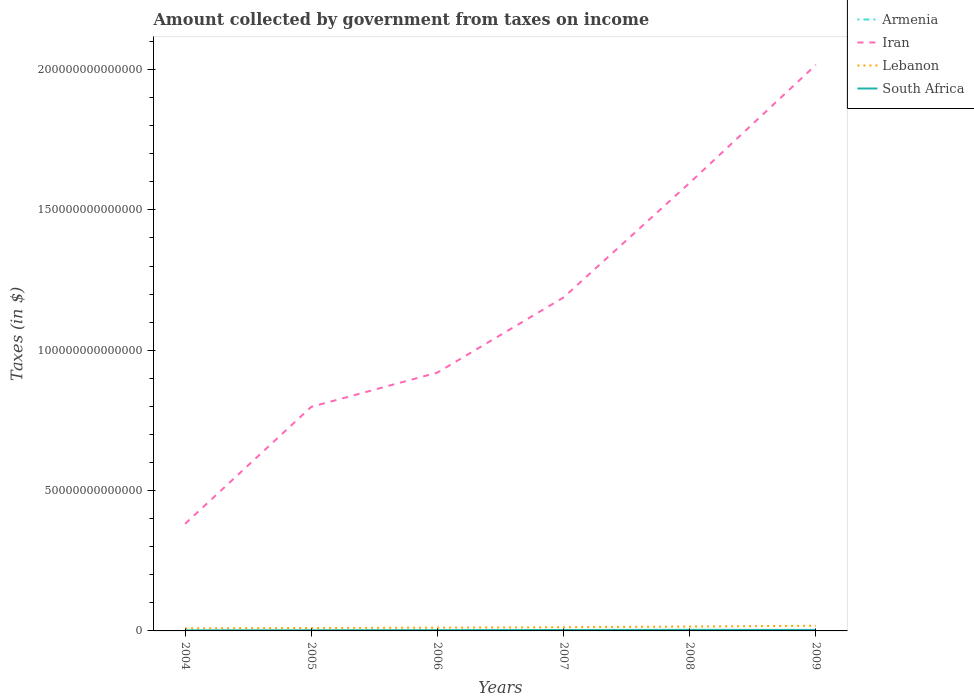Across all years, what is the maximum amount collected by government from taxes on income in South Africa?
Provide a short and direct response. 1.95e+11. What is the total amount collected by government from taxes on income in Iran in the graph?
Give a very brief answer. -1.22e+14. What is the difference between the highest and the second highest amount collected by government from taxes on income in Lebanon?
Give a very brief answer. 9.31e+11. Is the amount collected by government from taxes on income in Armenia strictly greater than the amount collected by government from taxes on income in South Africa over the years?
Offer a terse response. Yes. What is the difference between two consecutive major ticks on the Y-axis?
Ensure brevity in your answer.  5.00e+13. Does the graph contain grids?
Make the answer very short. No. How many legend labels are there?
Provide a short and direct response. 4. How are the legend labels stacked?
Your answer should be compact. Vertical. What is the title of the graph?
Give a very brief answer. Amount collected by government from taxes on income. What is the label or title of the Y-axis?
Your response must be concise. Taxes (in $). What is the Taxes (in $) in Armenia in 2004?
Offer a very short reply. 5.24e+1. What is the Taxes (in $) of Iran in 2004?
Your response must be concise. 3.82e+13. What is the Taxes (in $) of Lebanon in 2004?
Provide a succinct answer. 9.08e+11. What is the Taxes (in $) of South Africa in 2004?
Make the answer very short. 1.95e+11. What is the Taxes (in $) in Armenia in 2005?
Provide a short and direct response. 7.32e+1. What is the Taxes (in $) of Iran in 2005?
Your response must be concise. 7.98e+13. What is the Taxes (in $) of Lebanon in 2005?
Provide a short and direct response. 1.05e+12. What is the Taxes (in $) in South Africa in 2005?
Ensure brevity in your answer.  2.31e+11. What is the Taxes (in $) of Armenia in 2006?
Your answer should be compact. 1.01e+11. What is the Taxes (in $) in Iran in 2006?
Offer a terse response. 9.20e+13. What is the Taxes (in $) in Lebanon in 2006?
Provide a short and direct response. 1.17e+12. What is the Taxes (in $) in South Africa in 2006?
Give a very brief answer. 2.80e+11. What is the Taxes (in $) of Armenia in 2007?
Provide a succinct answer. 1.22e+11. What is the Taxes (in $) of Iran in 2007?
Your response must be concise. 1.19e+14. What is the Taxes (in $) in Lebanon in 2007?
Keep it short and to the point. 1.31e+12. What is the Taxes (in $) of South Africa in 2007?
Your response must be concise. 3.32e+11. What is the Taxes (in $) in Armenia in 2008?
Make the answer very short. 1.40e+11. What is the Taxes (in $) in Iran in 2008?
Provide a short and direct response. 1.60e+14. What is the Taxes (in $) of Lebanon in 2008?
Offer a terse response. 1.56e+12. What is the Taxes (in $) in South Africa in 2008?
Provide a succinct answer. 3.83e+11. What is the Taxes (in $) in Armenia in 2009?
Your answer should be compact. 1.42e+11. What is the Taxes (in $) in Iran in 2009?
Provide a short and direct response. 2.02e+14. What is the Taxes (in $) in Lebanon in 2009?
Your answer should be compact. 1.84e+12. What is the Taxes (in $) of South Africa in 2009?
Offer a very short reply. 3.59e+11. Across all years, what is the maximum Taxes (in $) of Armenia?
Make the answer very short. 1.42e+11. Across all years, what is the maximum Taxes (in $) of Iran?
Provide a short and direct response. 2.02e+14. Across all years, what is the maximum Taxes (in $) of Lebanon?
Ensure brevity in your answer.  1.84e+12. Across all years, what is the maximum Taxes (in $) of South Africa?
Provide a short and direct response. 3.83e+11. Across all years, what is the minimum Taxes (in $) in Armenia?
Make the answer very short. 5.24e+1. Across all years, what is the minimum Taxes (in $) of Iran?
Offer a terse response. 3.82e+13. Across all years, what is the minimum Taxes (in $) in Lebanon?
Offer a very short reply. 9.08e+11. Across all years, what is the minimum Taxes (in $) of South Africa?
Your answer should be very brief. 1.95e+11. What is the total Taxes (in $) in Armenia in the graph?
Your response must be concise. 6.31e+11. What is the total Taxes (in $) in Iran in the graph?
Offer a very short reply. 6.90e+14. What is the total Taxes (in $) in Lebanon in the graph?
Your response must be concise. 7.83e+12. What is the total Taxes (in $) in South Africa in the graph?
Your answer should be very brief. 1.78e+12. What is the difference between the Taxes (in $) of Armenia in 2004 and that in 2005?
Provide a succinct answer. -2.07e+1. What is the difference between the Taxes (in $) in Iran in 2004 and that in 2005?
Give a very brief answer. -4.17e+13. What is the difference between the Taxes (in $) in Lebanon in 2004 and that in 2005?
Provide a short and direct response. -1.39e+11. What is the difference between the Taxes (in $) of South Africa in 2004 and that in 2005?
Your answer should be compact. -3.56e+1. What is the difference between the Taxes (in $) in Armenia in 2004 and that in 2006?
Provide a succinct answer. -4.84e+1. What is the difference between the Taxes (in $) in Iran in 2004 and that in 2006?
Provide a short and direct response. -5.39e+13. What is the difference between the Taxes (in $) in Lebanon in 2004 and that in 2006?
Your answer should be compact. -2.58e+11. What is the difference between the Taxes (in $) in South Africa in 2004 and that in 2006?
Provide a succinct answer. -8.48e+1. What is the difference between the Taxes (in $) in Armenia in 2004 and that in 2007?
Offer a very short reply. -6.99e+1. What is the difference between the Taxes (in $) of Iran in 2004 and that in 2007?
Give a very brief answer. -8.06e+13. What is the difference between the Taxes (in $) of Lebanon in 2004 and that in 2007?
Ensure brevity in your answer.  -4.00e+11. What is the difference between the Taxes (in $) in South Africa in 2004 and that in 2007?
Give a very brief answer. -1.37e+11. What is the difference between the Taxes (in $) in Armenia in 2004 and that in 2008?
Offer a very short reply. -8.75e+1. What is the difference between the Taxes (in $) of Iran in 2004 and that in 2008?
Keep it short and to the point. -1.21e+14. What is the difference between the Taxes (in $) of Lebanon in 2004 and that in 2008?
Your answer should be very brief. -6.56e+11. What is the difference between the Taxes (in $) of South Africa in 2004 and that in 2008?
Provide a succinct answer. -1.88e+11. What is the difference between the Taxes (in $) of Armenia in 2004 and that in 2009?
Your answer should be compact. -8.96e+1. What is the difference between the Taxes (in $) in Iran in 2004 and that in 2009?
Provide a short and direct response. -1.63e+14. What is the difference between the Taxes (in $) in Lebanon in 2004 and that in 2009?
Your answer should be very brief. -9.31e+11. What is the difference between the Taxes (in $) in South Africa in 2004 and that in 2009?
Offer a terse response. -1.64e+11. What is the difference between the Taxes (in $) in Armenia in 2005 and that in 2006?
Keep it short and to the point. -2.76e+1. What is the difference between the Taxes (in $) of Iran in 2005 and that in 2006?
Offer a terse response. -1.22e+13. What is the difference between the Taxes (in $) of Lebanon in 2005 and that in 2006?
Provide a short and direct response. -1.19e+11. What is the difference between the Taxes (in $) of South Africa in 2005 and that in 2006?
Keep it short and to the point. -4.92e+1. What is the difference between the Taxes (in $) of Armenia in 2005 and that in 2007?
Provide a succinct answer. -4.92e+1. What is the difference between the Taxes (in $) of Iran in 2005 and that in 2007?
Provide a succinct answer. -3.90e+13. What is the difference between the Taxes (in $) of Lebanon in 2005 and that in 2007?
Offer a terse response. -2.61e+11. What is the difference between the Taxes (in $) in South Africa in 2005 and that in 2007?
Your answer should be very brief. -1.01e+11. What is the difference between the Taxes (in $) of Armenia in 2005 and that in 2008?
Your answer should be compact. -6.68e+1. What is the difference between the Taxes (in $) in Iran in 2005 and that in 2008?
Give a very brief answer. -7.98e+13. What is the difference between the Taxes (in $) in Lebanon in 2005 and that in 2008?
Offer a very short reply. -5.17e+11. What is the difference between the Taxes (in $) in South Africa in 2005 and that in 2008?
Your answer should be very brief. -1.53e+11. What is the difference between the Taxes (in $) of Armenia in 2005 and that in 2009?
Give a very brief answer. -6.89e+1. What is the difference between the Taxes (in $) in Iran in 2005 and that in 2009?
Provide a succinct answer. -1.22e+14. What is the difference between the Taxes (in $) in Lebanon in 2005 and that in 2009?
Make the answer very short. -7.92e+11. What is the difference between the Taxes (in $) in South Africa in 2005 and that in 2009?
Your answer should be compact. -1.28e+11. What is the difference between the Taxes (in $) in Armenia in 2006 and that in 2007?
Your response must be concise. -2.15e+1. What is the difference between the Taxes (in $) of Iran in 2006 and that in 2007?
Your answer should be very brief. -2.68e+13. What is the difference between the Taxes (in $) in Lebanon in 2006 and that in 2007?
Your response must be concise. -1.42e+11. What is the difference between the Taxes (in $) of South Africa in 2006 and that in 2007?
Your answer should be compact. -5.21e+1. What is the difference between the Taxes (in $) in Armenia in 2006 and that in 2008?
Make the answer very short. -3.92e+1. What is the difference between the Taxes (in $) in Iran in 2006 and that in 2008?
Provide a short and direct response. -6.76e+13. What is the difference between the Taxes (in $) of Lebanon in 2006 and that in 2008?
Give a very brief answer. -3.98e+11. What is the difference between the Taxes (in $) of South Africa in 2006 and that in 2008?
Ensure brevity in your answer.  -1.03e+11. What is the difference between the Taxes (in $) of Armenia in 2006 and that in 2009?
Provide a succinct answer. -4.12e+1. What is the difference between the Taxes (in $) in Iran in 2006 and that in 2009?
Keep it short and to the point. -1.10e+14. What is the difference between the Taxes (in $) of Lebanon in 2006 and that in 2009?
Give a very brief answer. -6.73e+11. What is the difference between the Taxes (in $) of South Africa in 2006 and that in 2009?
Make the answer very short. -7.91e+1. What is the difference between the Taxes (in $) of Armenia in 2007 and that in 2008?
Keep it short and to the point. -1.76e+1. What is the difference between the Taxes (in $) in Iran in 2007 and that in 2008?
Offer a very short reply. -4.08e+13. What is the difference between the Taxes (in $) of Lebanon in 2007 and that in 2008?
Provide a succinct answer. -2.56e+11. What is the difference between the Taxes (in $) in South Africa in 2007 and that in 2008?
Make the answer very short. -5.14e+1. What is the difference between the Taxes (in $) of Armenia in 2007 and that in 2009?
Keep it short and to the point. -1.97e+1. What is the difference between the Taxes (in $) of Iran in 2007 and that in 2009?
Ensure brevity in your answer.  -8.29e+13. What is the difference between the Taxes (in $) in Lebanon in 2007 and that in 2009?
Your answer should be very brief. -5.31e+11. What is the difference between the Taxes (in $) of South Africa in 2007 and that in 2009?
Give a very brief answer. -2.70e+1. What is the difference between the Taxes (in $) of Armenia in 2008 and that in 2009?
Offer a very short reply. -2.06e+09. What is the difference between the Taxes (in $) of Iran in 2008 and that in 2009?
Make the answer very short. -4.20e+13. What is the difference between the Taxes (in $) in Lebanon in 2008 and that in 2009?
Your answer should be compact. -2.75e+11. What is the difference between the Taxes (in $) in South Africa in 2008 and that in 2009?
Provide a short and direct response. 2.44e+1. What is the difference between the Taxes (in $) of Armenia in 2004 and the Taxes (in $) of Iran in 2005?
Provide a short and direct response. -7.98e+13. What is the difference between the Taxes (in $) in Armenia in 2004 and the Taxes (in $) in Lebanon in 2005?
Provide a succinct answer. -9.95e+11. What is the difference between the Taxes (in $) in Armenia in 2004 and the Taxes (in $) in South Africa in 2005?
Offer a very short reply. -1.78e+11. What is the difference between the Taxes (in $) in Iran in 2004 and the Taxes (in $) in Lebanon in 2005?
Offer a very short reply. 3.71e+13. What is the difference between the Taxes (in $) of Iran in 2004 and the Taxes (in $) of South Africa in 2005?
Offer a terse response. 3.79e+13. What is the difference between the Taxes (in $) in Lebanon in 2004 and the Taxes (in $) in South Africa in 2005?
Your answer should be compact. 6.77e+11. What is the difference between the Taxes (in $) in Armenia in 2004 and the Taxes (in $) in Iran in 2006?
Give a very brief answer. -9.20e+13. What is the difference between the Taxes (in $) in Armenia in 2004 and the Taxes (in $) in Lebanon in 2006?
Offer a terse response. -1.11e+12. What is the difference between the Taxes (in $) in Armenia in 2004 and the Taxes (in $) in South Africa in 2006?
Your answer should be very brief. -2.28e+11. What is the difference between the Taxes (in $) of Iran in 2004 and the Taxes (in $) of Lebanon in 2006?
Offer a very short reply. 3.70e+13. What is the difference between the Taxes (in $) in Iran in 2004 and the Taxes (in $) in South Africa in 2006?
Make the answer very short. 3.79e+13. What is the difference between the Taxes (in $) of Lebanon in 2004 and the Taxes (in $) of South Africa in 2006?
Give a very brief answer. 6.28e+11. What is the difference between the Taxes (in $) of Armenia in 2004 and the Taxes (in $) of Iran in 2007?
Provide a short and direct response. -1.19e+14. What is the difference between the Taxes (in $) in Armenia in 2004 and the Taxes (in $) in Lebanon in 2007?
Your answer should be compact. -1.26e+12. What is the difference between the Taxes (in $) of Armenia in 2004 and the Taxes (in $) of South Africa in 2007?
Make the answer very short. -2.80e+11. What is the difference between the Taxes (in $) of Iran in 2004 and the Taxes (in $) of Lebanon in 2007?
Offer a very short reply. 3.69e+13. What is the difference between the Taxes (in $) in Iran in 2004 and the Taxes (in $) in South Africa in 2007?
Make the answer very short. 3.78e+13. What is the difference between the Taxes (in $) in Lebanon in 2004 and the Taxes (in $) in South Africa in 2007?
Offer a terse response. 5.76e+11. What is the difference between the Taxes (in $) of Armenia in 2004 and the Taxes (in $) of Iran in 2008?
Give a very brief answer. -1.60e+14. What is the difference between the Taxes (in $) in Armenia in 2004 and the Taxes (in $) in Lebanon in 2008?
Your answer should be very brief. -1.51e+12. What is the difference between the Taxes (in $) in Armenia in 2004 and the Taxes (in $) in South Africa in 2008?
Offer a terse response. -3.31e+11. What is the difference between the Taxes (in $) in Iran in 2004 and the Taxes (in $) in Lebanon in 2008?
Provide a succinct answer. 3.66e+13. What is the difference between the Taxes (in $) of Iran in 2004 and the Taxes (in $) of South Africa in 2008?
Make the answer very short. 3.78e+13. What is the difference between the Taxes (in $) in Lebanon in 2004 and the Taxes (in $) in South Africa in 2008?
Keep it short and to the point. 5.24e+11. What is the difference between the Taxes (in $) of Armenia in 2004 and the Taxes (in $) of Iran in 2009?
Give a very brief answer. -2.02e+14. What is the difference between the Taxes (in $) in Armenia in 2004 and the Taxes (in $) in Lebanon in 2009?
Your answer should be compact. -1.79e+12. What is the difference between the Taxes (in $) of Armenia in 2004 and the Taxes (in $) of South Africa in 2009?
Keep it short and to the point. -3.07e+11. What is the difference between the Taxes (in $) in Iran in 2004 and the Taxes (in $) in Lebanon in 2009?
Make the answer very short. 3.63e+13. What is the difference between the Taxes (in $) in Iran in 2004 and the Taxes (in $) in South Africa in 2009?
Your answer should be compact. 3.78e+13. What is the difference between the Taxes (in $) of Lebanon in 2004 and the Taxes (in $) of South Africa in 2009?
Ensure brevity in your answer.  5.49e+11. What is the difference between the Taxes (in $) of Armenia in 2005 and the Taxes (in $) of Iran in 2006?
Your answer should be very brief. -9.20e+13. What is the difference between the Taxes (in $) in Armenia in 2005 and the Taxes (in $) in Lebanon in 2006?
Offer a very short reply. -1.09e+12. What is the difference between the Taxes (in $) of Armenia in 2005 and the Taxes (in $) of South Africa in 2006?
Offer a terse response. -2.07e+11. What is the difference between the Taxes (in $) in Iran in 2005 and the Taxes (in $) in Lebanon in 2006?
Provide a short and direct response. 7.87e+13. What is the difference between the Taxes (in $) of Iran in 2005 and the Taxes (in $) of South Africa in 2006?
Offer a very short reply. 7.96e+13. What is the difference between the Taxes (in $) of Lebanon in 2005 and the Taxes (in $) of South Africa in 2006?
Offer a terse response. 7.67e+11. What is the difference between the Taxes (in $) of Armenia in 2005 and the Taxes (in $) of Iran in 2007?
Provide a short and direct response. -1.19e+14. What is the difference between the Taxes (in $) of Armenia in 2005 and the Taxes (in $) of Lebanon in 2007?
Make the answer very short. -1.23e+12. What is the difference between the Taxes (in $) in Armenia in 2005 and the Taxes (in $) in South Africa in 2007?
Your response must be concise. -2.59e+11. What is the difference between the Taxes (in $) of Iran in 2005 and the Taxes (in $) of Lebanon in 2007?
Ensure brevity in your answer.  7.85e+13. What is the difference between the Taxes (in $) of Iran in 2005 and the Taxes (in $) of South Africa in 2007?
Make the answer very short. 7.95e+13. What is the difference between the Taxes (in $) of Lebanon in 2005 and the Taxes (in $) of South Africa in 2007?
Offer a very short reply. 7.15e+11. What is the difference between the Taxes (in $) of Armenia in 2005 and the Taxes (in $) of Iran in 2008?
Provide a succinct answer. -1.60e+14. What is the difference between the Taxes (in $) of Armenia in 2005 and the Taxes (in $) of Lebanon in 2008?
Offer a very short reply. -1.49e+12. What is the difference between the Taxes (in $) in Armenia in 2005 and the Taxes (in $) in South Africa in 2008?
Offer a terse response. -3.10e+11. What is the difference between the Taxes (in $) of Iran in 2005 and the Taxes (in $) of Lebanon in 2008?
Your response must be concise. 7.83e+13. What is the difference between the Taxes (in $) of Iran in 2005 and the Taxes (in $) of South Africa in 2008?
Provide a succinct answer. 7.95e+13. What is the difference between the Taxes (in $) in Lebanon in 2005 and the Taxes (in $) in South Africa in 2008?
Keep it short and to the point. 6.64e+11. What is the difference between the Taxes (in $) of Armenia in 2005 and the Taxes (in $) of Iran in 2009?
Give a very brief answer. -2.02e+14. What is the difference between the Taxes (in $) of Armenia in 2005 and the Taxes (in $) of Lebanon in 2009?
Your answer should be very brief. -1.77e+12. What is the difference between the Taxes (in $) of Armenia in 2005 and the Taxes (in $) of South Africa in 2009?
Ensure brevity in your answer.  -2.86e+11. What is the difference between the Taxes (in $) in Iran in 2005 and the Taxes (in $) in Lebanon in 2009?
Ensure brevity in your answer.  7.80e+13. What is the difference between the Taxes (in $) in Iran in 2005 and the Taxes (in $) in South Africa in 2009?
Offer a terse response. 7.95e+13. What is the difference between the Taxes (in $) of Lebanon in 2005 and the Taxes (in $) of South Africa in 2009?
Your response must be concise. 6.88e+11. What is the difference between the Taxes (in $) in Armenia in 2006 and the Taxes (in $) in Iran in 2007?
Give a very brief answer. -1.19e+14. What is the difference between the Taxes (in $) of Armenia in 2006 and the Taxes (in $) of Lebanon in 2007?
Offer a very short reply. -1.21e+12. What is the difference between the Taxes (in $) in Armenia in 2006 and the Taxes (in $) in South Africa in 2007?
Your response must be concise. -2.31e+11. What is the difference between the Taxes (in $) in Iran in 2006 and the Taxes (in $) in Lebanon in 2007?
Your response must be concise. 9.07e+13. What is the difference between the Taxes (in $) in Iran in 2006 and the Taxes (in $) in South Africa in 2007?
Keep it short and to the point. 9.17e+13. What is the difference between the Taxes (in $) of Lebanon in 2006 and the Taxes (in $) of South Africa in 2007?
Ensure brevity in your answer.  8.34e+11. What is the difference between the Taxes (in $) of Armenia in 2006 and the Taxes (in $) of Iran in 2008?
Make the answer very short. -1.60e+14. What is the difference between the Taxes (in $) in Armenia in 2006 and the Taxes (in $) in Lebanon in 2008?
Provide a short and direct response. -1.46e+12. What is the difference between the Taxes (in $) of Armenia in 2006 and the Taxes (in $) of South Africa in 2008?
Your answer should be very brief. -2.83e+11. What is the difference between the Taxes (in $) in Iran in 2006 and the Taxes (in $) in Lebanon in 2008?
Offer a very short reply. 9.05e+13. What is the difference between the Taxes (in $) of Iran in 2006 and the Taxes (in $) of South Africa in 2008?
Ensure brevity in your answer.  9.17e+13. What is the difference between the Taxes (in $) of Lebanon in 2006 and the Taxes (in $) of South Africa in 2008?
Offer a very short reply. 7.83e+11. What is the difference between the Taxes (in $) in Armenia in 2006 and the Taxes (in $) in Iran in 2009?
Provide a succinct answer. -2.02e+14. What is the difference between the Taxes (in $) of Armenia in 2006 and the Taxes (in $) of Lebanon in 2009?
Offer a terse response. -1.74e+12. What is the difference between the Taxes (in $) of Armenia in 2006 and the Taxes (in $) of South Africa in 2009?
Ensure brevity in your answer.  -2.58e+11. What is the difference between the Taxes (in $) in Iran in 2006 and the Taxes (in $) in Lebanon in 2009?
Keep it short and to the point. 9.02e+13. What is the difference between the Taxes (in $) in Iran in 2006 and the Taxes (in $) in South Africa in 2009?
Give a very brief answer. 9.17e+13. What is the difference between the Taxes (in $) of Lebanon in 2006 and the Taxes (in $) of South Africa in 2009?
Ensure brevity in your answer.  8.07e+11. What is the difference between the Taxes (in $) in Armenia in 2007 and the Taxes (in $) in Iran in 2008?
Make the answer very short. -1.60e+14. What is the difference between the Taxes (in $) of Armenia in 2007 and the Taxes (in $) of Lebanon in 2008?
Your answer should be very brief. -1.44e+12. What is the difference between the Taxes (in $) of Armenia in 2007 and the Taxes (in $) of South Africa in 2008?
Give a very brief answer. -2.61e+11. What is the difference between the Taxes (in $) of Iran in 2007 and the Taxes (in $) of Lebanon in 2008?
Your answer should be compact. 1.17e+14. What is the difference between the Taxes (in $) in Iran in 2007 and the Taxes (in $) in South Africa in 2008?
Offer a terse response. 1.18e+14. What is the difference between the Taxes (in $) of Lebanon in 2007 and the Taxes (in $) of South Africa in 2008?
Your answer should be very brief. 9.25e+11. What is the difference between the Taxes (in $) in Armenia in 2007 and the Taxes (in $) in Iran in 2009?
Your answer should be compact. -2.02e+14. What is the difference between the Taxes (in $) of Armenia in 2007 and the Taxes (in $) of Lebanon in 2009?
Your answer should be very brief. -1.72e+12. What is the difference between the Taxes (in $) of Armenia in 2007 and the Taxes (in $) of South Africa in 2009?
Provide a succinct answer. -2.37e+11. What is the difference between the Taxes (in $) in Iran in 2007 and the Taxes (in $) in Lebanon in 2009?
Give a very brief answer. 1.17e+14. What is the difference between the Taxes (in $) in Iran in 2007 and the Taxes (in $) in South Africa in 2009?
Provide a succinct answer. 1.18e+14. What is the difference between the Taxes (in $) of Lebanon in 2007 and the Taxes (in $) of South Africa in 2009?
Your response must be concise. 9.49e+11. What is the difference between the Taxes (in $) in Armenia in 2008 and the Taxes (in $) in Iran in 2009?
Offer a very short reply. -2.02e+14. What is the difference between the Taxes (in $) of Armenia in 2008 and the Taxes (in $) of Lebanon in 2009?
Offer a terse response. -1.70e+12. What is the difference between the Taxes (in $) of Armenia in 2008 and the Taxes (in $) of South Africa in 2009?
Give a very brief answer. -2.19e+11. What is the difference between the Taxes (in $) of Iran in 2008 and the Taxes (in $) of Lebanon in 2009?
Make the answer very short. 1.58e+14. What is the difference between the Taxes (in $) in Iran in 2008 and the Taxes (in $) in South Africa in 2009?
Keep it short and to the point. 1.59e+14. What is the difference between the Taxes (in $) of Lebanon in 2008 and the Taxes (in $) of South Africa in 2009?
Give a very brief answer. 1.21e+12. What is the average Taxes (in $) in Armenia per year?
Keep it short and to the point. 1.05e+11. What is the average Taxes (in $) in Iran per year?
Offer a terse response. 1.15e+14. What is the average Taxes (in $) in Lebanon per year?
Offer a very short reply. 1.31e+12. What is the average Taxes (in $) of South Africa per year?
Give a very brief answer. 2.97e+11. In the year 2004, what is the difference between the Taxes (in $) in Armenia and Taxes (in $) in Iran?
Your answer should be compact. -3.81e+13. In the year 2004, what is the difference between the Taxes (in $) of Armenia and Taxes (in $) of Lebanon?
Make the answer very short. -8.55e+11. In the year 2004, what is the difference between the Taxes (in $) in Armenia and Taxes (in $) in South Africa?
Your answer should be very brief. -1.43e+11. In the year 2004, what is the difference between the Taxes (in $) in Iran and Taxes (in $) in Lebanon?
Provide a short and direct response. 3.73e+13. In the year 2004, what is the difference between the Taxes (in $) in Iran and Taxes (in $) in South Africa?
Your answer should be compact. 3.80e+13. In the year 2004, what is the difference between the Taxes (in $) in Lebanon and Taxes (in $) in South Africa?
Your answer should be very brief. 7.13e+11. In the year 2005, what is the difference between the Taxes (in $) of Armenia and Taxes (in $) of Iran?
Provide a short and direct response. -7.98e+13. In the year 2005, what is the difference between the Taxes (in $) of Armenia and Taxes (in $) of Lebanon?
Offer a terse response. -9.74e+11. In the year 2005, what is the difference between the Taxes (in $) of Armenia and Taxes (in $) of South Africa?
Make the answer very short. -1.58e+11. In the year 2005, what is the difference between the Taxes (in $) of Iran and Taxes (in $) of Lebanon?
Provide a short and direct response. 7.88e+13. In the year 2005, what is the difference between the Taxes (in $) of Iran and Taxes (in $) of South Africa?
Your response must be concise. 7.96e+13. In the year 2005, what is the difference between the Taxes (in $) in Lebanon and Taxes (in $) in South Africa?
Your response must be concise. 8.16e+11. In the year 2006, what is the difference between the Taxes (in $) of Armenia and Taxes (in $) of Iran?
Provide a short and direct response. -9.19e+13. In the year 2006, what is the difference between the Taxes (in $) in Armenia and Taxes (in $) in Lebanon?
Keep it short and to the point. -1.07e+12. In the year 2006, what is the difference between the Taxes (in $) in Armenia and Taxes (in $) in South Africa?
Offer a terse response. -1.79e+11. In the year 2006, what is the difference between the Taxes (in $) in Iran and Taxes (in $) in Lebanon?
Ensure brevity in your answer.  9.09e+13. In the year 2006, what is the difference between the Taxes (in $) in Iran and Taxes (in $) in South Africa?
Your answer should be compact. 9.18e+13. In the year 2006, what is the difference between the Taxes (in $) of Lebanon and Taxes (in $) of South Africa?
Your answer should be very brief. 8.86e+11. In the year 2007, what is the difference between the Taxes (in $) in Armenia and Taxes (in $) in Iran?
Your answer should be compact. -1.19e+14. In the year 2007, what is the difference between the Taxes (in $) of Armenia and Taxes (in $) of Lebanon?
Your answer should be very brief. -1.19e+12. In the year 2007, what is the difference between the Taxes (in $) in Armenia and Taxes (in $) in South Africa?
Provide a succinct answer. -2.10e+11. In the year 2007, what is the difference between the Taxes (in $) in Iran and Taxes (in $) in Lebanon?
Offer a terse response. 1.17e+14. In the year 2007, what is the difference between the Taxes (in $) in Iran and Taxes (in $) in South Africa?
Your answer should be compact. 1.18e+14. In the year 2007, what is the difference between the Taxes (in $) of Lebanon and Taxes (in $) of South Africa?
Your response must be concise. 9.76e+11. In the year 2008, what is the difference between the Taxes (in $) in Armenia and Taxes (in $) in Iran?
Provide a succinct answer. -1.60e+14. In the year 2008, what is the difference between the Taxes (in $) of Armenia and Taxes (in $) of Lebanon?
Keep it short and to the point. -1.42e+12. In the year 2008, what is the difference between the Taxes (in $) of Armenia and Taxes (in $) of South Africa?
Keep it short and to the point. -2.44e+11. In the year 2008, what is the difference between the Taxes (in $) of Iran and Taxes (in $) of Lebanon?
Your answer should be compact. 1.58e+14. In the year 2008, what is the difference between the Taxes (in $) in Iran and Taxes (in $) in South Africa?
Offer a very short reply. 1.59e+14. In the year 2008, what is the difference between the Taxes (in $) of Lebanon and Taxes (in $) of South Africa?
Your answer should be very brief. 1.18e+12. In the year 2009, what is the difference between the Taxes (in $) in Armenia and Taxes (in $) in Iran?
Your answer should be very brief. -2.02e+14. In the year 2009, what is the difference between the Taxes (in $) of Armenia and Taxes (in $) of Lebanon?
Make the answer very short. -1.70e+12. In the year 2009, what is the difference between the Taxes (in $) of Armenia and Taxes (in $) of South Africa?
Your response must be concise. -2.17e+11. In the year 2009, what is the difference between the Taxes (in $) in Iran and Taxes (in $) in Lebanon?
Your answer should be compact. 2.00e+14. In the year 2009, what is the difference between the Taxes (in $) of Iran and Taxes (in $) of South Africa?
Give a very brief answer. 2.01e+14. In the year 2009, what is the difference between the Taxes (in $) of Lebanon and Taxes (in $) of South Africa?
Your answer should be compact. 1.48e+12. What is the ratio of the Taxes (in $) in Armenia in 2004 to that in 2005?
Provide a succinct answer. 0.72. What is the ratio of the Taxes (in $) of Iran in 2004 to that in 2005?
Give a very brief answer. 0.48. What is the ratio of the Taxes (in $) in Lebanon in 2004 to that in 2005?
Your answer should be very brief. 0.87. What is the ratio of the Taxes (in $) of South Africa in 2004 to that in 2005?
Your response must be concise. 0.85. What is the ratio of the Taxes (in $) in Armenia in 2004 to that in 2006?
Your answer should be very brief. 0.52. What is the ratio of the Taxes (in $) of Iran in 2004 to that in 2006?
Your answer should be compact. 0.41. What is the ratio of the Taxes (in $) of Lebanon in 2004 to that in 2006?
Your response must be concise. 0.78. What is the ratio of the Taxes (in $) in South Africa in 2004 to that in 2006?
Ensure brevity in your answer.  0.7. What is the ratio of the Taxes (in $) of Armenia in 2004 to that in 2007?
Your response must be concise. 0.43. What is the ratio of the Taxes (in $) of Iran in 2004 to that in 2007?
Ensure brevity in your answer.  0.32. What is the ratio of the Taxes (in $) in Lebanon in 2004 to that in 2007?
Your answer should be very brief. 0.69. What is the ratio of the Taxes (in $) of South Africa in 2004 to that in 2007?
Make the answer very short. 0.59. What is the ratio of the Taxes (in $) in Armenia in 2004 to that in 2008?
Make the answer very short. 0.37. What is the ratio of the Taxes (in $) in Iran in 2004 to that in 2008?
Make the answer very short. 0.24. What is the ratio of the Taxes (in $) of Lebanon in 2004 to that in 2008?
Your answer should be very brief. 0.58. What is the ratio of the Taxes (in $) of South Africa in 2004 to that in 2008?
Keep it short and to the point. 0.51. What is the ratio of the Taxes (in $) of Armenia in 2004 to that in 2009?
Provide a short and direct response. 0.37. What is the ratio of the Taxes (in $) in Iran in 2004 to that in 2009?
Keep it short and to the point. 0.19. What is the ratio of the Taxes (in $) in Lebanon in 2004 to that in 2009?
Your answer should be compact. 0.49. What is the ratio of the Taxes (in $) of South Africa in 2004 to that in 2009?
Offer a terse response. 0.54. What is the ratio of the Taxes (in $) of Armenia in 2005 to that in 2006?
Give a very brief answer. 0.73. What is the ratio of the Taxes (in $) in Iran in 2005 to that in 2006?
Ensure brevity in your answer.  0.87. What is the ratio of the Taxes (in $) in Lebanon in 2005 to that in 2006?
Offer a terse response. 0.9. What is the ratio of the Taxes (in $) of South Africa in 2005 to that in 2006?
Keep it short and to the point. 0.82. What is the ratio of the Taxes (in $) in Armenia in 2005 to that in 2007?
Keep it short and to the point. 0.6. What is the ratio of the Taxes (in $) in Iran in 2005 to that in 2007?
Your response must be concise. 0.67. What is the ratio of the Taxes (in $) in Lebanon in 2005 to that in 2007?
Offer a terse response. 0.8. What is the ratio of the Taxes (in $) of South Africa in 2005 to that in 2007?
Provide a short and direct response. 0.7. What is the ratio of the Taxes (in $) in Armenia in 2005 to that in 2008?
Give a very brief answer. 0.52. What is the ratio of the Taxes (in $) in Iran in 2005 to that in 2008?
Provide a short and direct response. 0.5. What is the ratio of the Taxes (in $) of Lebanon in 2005 to that in 2008?
Provide a succinct answer. 0.67. What is the ratio of the Taxes (in $) of South Africa in 2005 to that in 2008?
Provide a succinct answer. 0.6. What is the ratio of the Taxes (in $) of Armenia in 2005 to that in 2009?
Offer a very short reply. 0.52. What is the ratio of the Taxes (in $) of Iran in 2005 to that in 2009?
Provide a succinct answer. 0.4. What is the ratio of the Taxes (in $) in Lebanon in 2005 to that in 2009?
Ensure brevity in your answer.  0.57. What is the ratio of the Taxes (in $) of South Africa in 2005 to that in 2009?
Ensure brevity in your answer.  0.64. What is the ratio of the Taxes (in $) in Armenia in 2006 to that in 2007?
Offer a terse response. 0.82. What is the ratio of the Taxes (in $) in Iran in 2006 to that in 2007?
Ensure brevity in your answer.  0.77. What is the ratio of the Taxes (in $) of Lebanon in 2006 to that in 2007?
Offer a terse response. 0.89. What is the ratio of the Taxes (in $) in South Africa in 2006 to that in 2007?
Keep it short and to the point. 0.84. What is the ratio of the Taxes (in $) in Armenia in 2006 to that in 2008?
Offer a terse response. 0.72. What is the ratio of the Taxes (in $) in Iran in 2006 to that in 2008?
Ensure brevity in your answer.  0.58. What is the ratio of the Taxes (in $) in Lebanon in 2006 to that in 2008?
Offer a very short reply. 0.75. What is the ratio of the Taxes (in $) in South Africa in 2006 to that in 2008?
Provide a short and direct response. 0.73. What is the ratio of the Taxes (in $) in Armenia in 2006 to that in 2009?
Provide a short and direct response. 0.71. What is the ratio of the Taxes (in $) of Iran in 2006 to that in 2009?
Make the answer very short. 0.46. What is the ratio of the Taxes (in $) of Lebanon in 2006 to that in 2009?
Ensure brevity in your answer.  0.63. What is the ratio of the Taxes (in $) of South Africa in 2006 to that in 2009?
Give a very brief answer. 0.78. What is the ratio of the Taxes (in $) of Armenia in 2007 to that in 2008?
Make the answer very short. 0.87. What is the ratio of the Taxes (in $) in Iran in 2007 to that in 2008?
Ensure brevity in your answer.  0.74. What is the ratio of the Taxes (in $) of Lebanon in 2007 to that in 2008?
Give a very brief answer. 0.84. What is the ratio of the Taxes (in $) of South Africa in 2007 to that in 2008?
Your answer should be compact. 0.87. What is the ratio of the Taxes (in $) of Armenia in 2007 to that in 2009?
Make the answer very short. 0.86. What is the ratio of the Taxes (in $) of Iran in 2007 to that in 2009?
Your response must be concise. 0.59. What is the ratio of the Taxes (in $) in Lebanon in 2007 to that in 2009?
Keep it short and to the point. 0.71. What is the ratio of the Taxes (in $) in South Africa in 2007 to that in 2009?
Ensure brevity in your answer.  0.92. What is the ratio of the Taxes (in $) in Armenia in 2008 to that in 2009?
Ensure brevity in your answer.  0.99. What is the ratio of the Taxes (in $) of Iran in 2008 to that in 2009?
Make the answer very short. 0.79. What is the ratio of the Taxes (in $) in Lebanon in 2008 to that in 2009?
Your answer should be compact. 0.85. What is the ratio of the Taxes (in $) of South Africa in 2008 to that in 2009?
Your answer should be compact. 1.07. What is the difference between the highest and the second highest Taxes (in $) of Armenia?
Your answer should be very brief. 2.06e+09. What is the difference between the highest and the second highest Taxes (in $) of Iran?
Offer a very short reply. 4.20e+13. What is the difference between the highest and the second highest Taxes (in $) of Lebanon?
Offer a terse response. 2.75e+11. What is the difference between the highest and the second highest Taxes (in $) in South Africa?
Offer a very short reply. 2.44e+1. What is the difference between the highest and the lowest Taxes (in $) in Armenia?
Make the answer very short. 8.96e+1. What is the difference between the highest and the lowest Taxes (in $) in Iran?
Provide a short and direct response. 1.63e+14. What is the difference between the highest and the lowest Taxes (in $) in Lebanon?
Provide a succinct answer. 9.31e+11. What is the difference between the highest and the lowest Taxes (in $) in South Africa?
Make the answer very short. 1.88e+11. 